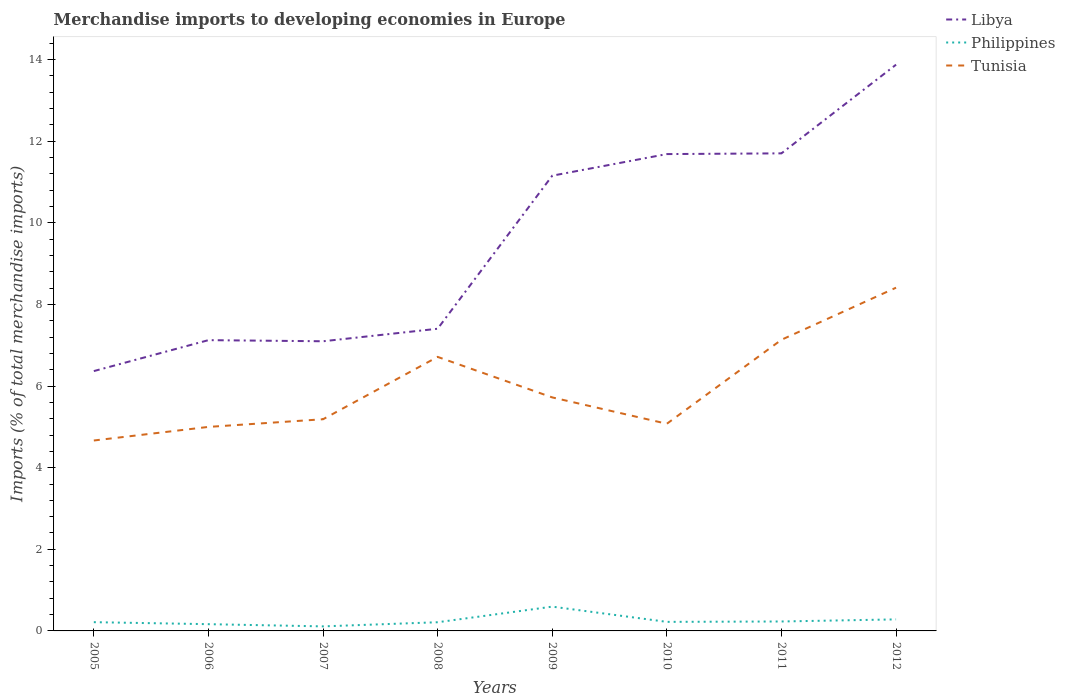Is the number of lines equal to the number of legend labels?
Provide a short and direct response. Yes. Across all years, what is the maximum percentage total merchandise imports in Philippines?
Give a very brief answer. 0.11. What is the total percentage total merchandise imports in Libya in the graph?
Offer a terse response. -4.6. What is the difference between the highest and the second highest percentage total merchandise imports in Libya?
Give a very brief answer. 7.51. Is the percentage total merchandise imports in Philippines strictly greater than the percentage total merchandise imports in Libya over the years?
Give a very brief answer. Yes. How many lines are there?
Your response must be concise. 3. What is the difference between two consecutive major ticks on the Y-axis?
Provide a short and direct response. 2. Are the values on the major ticks of Y-axis written in scientific E-notation?
Your answer should be very brief. No. How many legend labels are there?
Give a very brief answer. 3. What is the title of the graph?
Make the answer very short. Merchandise imports to developing economies in Europe. Does "Suriname" appear as one of the legend labels in the graph?
Your answer should be very brief. No. What is the label or title of the Y-axis?
Offer a terse response. Imports (% of total merchandise imports). What is the Imports (% of total merchandise imports) in Libya in 2005?
Offer a very short reply. 6.37. What is the Imports (% of total merchandise imports) of Philippines in 2005?
Your answer should be very brief. 0.21. What is the Imports (% of total merchandise imports) of Tunisia in 2005?
Give a very brief answer. 4.67. What is the Imports (% of total merchandise imports) in Libya in 2006?
Provide a succinct answer. 7.13. What is the Imports (% of total merchandise imports) of Philippines in 2006?
Ensure brevity in your answer.  0.17. What is the Imports (% of total merchandise imports) of Tunisia in 2006?
Keep it short and to the point. 5. What is the Imports (% of total merchandise imports) in Libya in 2007?
Provide a succinct answer. 7.1. What is the Imports (% of total merchandise imports) in Philippines in 2007?
Your response must be concise. 0.11. What is the Imports (% of total merchandise imports) of Tunisia in 2007?
Offer a terse response. 5.19. What is the Imports (% of total merchandise imports) in Libya in 2008?
Your answer should be very brief. 7.41. What is the Imports (% of total merchandise imports) of Philippines in 2008?
Provide a succinct answer. 0.21. What is the Imports (% of total merchandise imports) in Tunisia in 2008?
Provide a short and direct response. 6.72. What is the Imports (% of total merchandise imports) in Libya in 2009?
Make the answer very short. 11.16. What is the Imports (% of total merchandise imports) of Philippines in 2009?
Your answer should be very brief. 0.6. What is the Imports (% of total merchandise imports) of Tunisia in 2009?
Provide a succinct answer. 5.72. What is the Imports (% of total merchandise imports) in Libya in 2010?
Your response must be concise. 11.69. What is the Imports (% of total merchandise imports) in Philippines in 2010?
Make the answer very short. 0.22. What is the Imports (% of total merchandise imports) in Tunisia in 2010?
Keep it short and to the point. 5.08. What is the Imports (% of total merchandise imports) of Libya in 2011?
Give a very brief answer. 11.7. What is the Imports (% of total merchandise imports) in Philippines in 2011?
Keep it short and to the point. 0.23. What is the Imports (% of total merchandise imports) in Tunisia in 2011?
Offer a very short reply. 7.14. What is the Imports (% of total merchandise imports) of Libya in 2012?
Your answer should be very brief. 13.88. What is the Imports (% of total merchandise imports) in Philippines in 2012?
Ensure brevity in your answer.  0.28. What is the Imports (% of total merchandise imports) in Tunisia in 2012?
Offer a terse response. 8.41. Across all years, what is the maximum Imports (% of total merchandise imports) in Libya?
Offer a very short reply. 13.88. Across all years, what is the maximum Imports (% of total merchandise imports) of Philippines?
Keep it short and to the point. 0.6. Across all years, what is the maximum Imports (% of total merchandise imports) in Tunisia?
Offer a very short reply. 8.41. Across all years, what is the minimum Imports (% of total merchandise imports) of Libya?
Make the answer very short. 6.37. Across all years, what is the minimum Imports (% of total merchandise imports) of Philippines?
Offer a terse response. 0.11. Across all years, what is the minimum Imports (% of total merchandise imports) of Tunisia?
Provide a short and direct response. 4.67. What is the total Imports (% of total merchandise imports) in Libya in the graph?
Make the answer very short. 76.42. What is the total Imports (% of total merchandise imports) in Philippines in the graph?
Your response must be concise. 2.04. What is the total Imports (% of total merchandise imports) in Tunisia in the graph?
Offer a terse response. 47.91. What is the difference between the Imports (% of total merchandise imports) of Libya in 2005 and that in 2006?
Ensure brevity in your answer.  -0.76. What is the difference between the Imports (% of total merchandise imports) of Philippines in 2005 and that in 2006?
Keep it short and to the point. 0.05. What is the difference between the Imports (% of total merchandise imports) of Tunisia in 2005 and that in 2006?
Ensure brevity in your answer.  -0.33. What is the difference between the Imports (% of total merchandise imports) in Libya in 2005 and that in 2007?
Your answer should be very brief. -0.73. What is the difference between the Imports (% of total merchandise imports) of Philippines in 2005 and that in 2007?
Your answer should be compact. 0.1. What is the difference between the Imports (% of total merchandise imports) of Tunisia in 2005 and that in 2007?
Offer a very short reply. -0.52. What is the difference between the Imports (% of total merchandise imports) in Libya in 2005 and that in 2008?
Offer a very short reply. -1.04. What is the difference between the Imports (% of total merchandise imports) of Philippines in 2005 and that in 2008?
Your answer should be very brief. 0. What is the difference between the Imports (% of total merchandise imports) of Tunisia in 2005 and that in 2008?
Your answer should be very brief. -2.05. What is the difference between the Imports (% of total merchandise imports) in Libya in 2005 and that in 2009?
Provide a succinct answer. -4.79. What is the difference between the Imports (% of total merchandise imports) of Philippines in 2005 and that in 2009?
Your response must be concise. -0.38. What is the difference between the Imports (% of total merchandise imports) of Tunisia in 2005 and that in 2009?
Your answer should be compact. -1.06. What is the difference between the Imports (% of total merchandise imports) in Libya in 2005 and that in 2010?
Provide a succinct answer. -5.32. What is the difference between the Imports (% of total merchandise imports) in Philippines in 2005 and that in 2010?
Keep it short and to the point. -0.01. What is the difference between the Imports (% of total merchandise imports) in Tunisia in 2005 and that in 2010?
Make the answer very short. -0.41. What is the difference between the Imports (% of total merchandise imports) in Libya in 2005 and that in 2011?
Your answer should be compact. -5.34. What is the difference between the Imports (% of total merchandise imports) of Philippines in 2005 and that in 2011?
Provide a succinct answer. -0.02. What is the difference between the Imports (% of total merchandise imports) of Tunisia in 2005 and that in 2011?
Offer a terse response. -2.47. What is the difference between the Imports (% of total merchandise imports) of Libya in 2005 and that in 2012?
Offer a very short reply. -7.51. What is the difference between the Imports (% of total merchandise imports) in Philippines in 2005 and that in 2012?
Your answer should be very brief. -0.07. What is the difference between the Imports (% of total merchandise imports) in Tunisia in 2005 and that in 2012?
Offer a terse response. -3.75. What is the difference between the Imports (% of total merchandise imports) of Libya in 2006 and that in 2007?
Your response must be concise. 0.03. What is the difference between the Imports (% of total merchandise imports) in Philippines in 2006 and that in 2007?
Your response must be concise. 0.05. What is the difference between the Imports (% of total merchandise imports) of Tunisia in 2006 and that in 2007?
Keep it short and to the point. -0.19. What is the difference between the Imports (% of total merchandise imports) in Libya in 2006 and that in 2008?
Offer a terse response. -0.28. What is the difference between the Imports (% of total merchandise imports) of Philippines in 2006 and that in 2008?
Offer a terse response. -0.05. What is the difference between the Imports (% of total merchandise imports) in Tunisia in 2006 and that in 2008?
Offer a terse response. -1.72. What is the difference between the Imports (% of total merchandise imports) of Libya in 2006 and that in 2009?
Offer a very short reply. -4.03. What is the difference between the Imports (% of total merchandise imports) of Philippines in 2006 and that in 2009?
Make the answer very short. -0.43. What is the difference between the Imports (% of total merchandise imports) of Tunisia in 2006 and that in 2009?
Offer a very short reply. -0.72. What is the difference between the Imports (% of total merchandise imports) of Libya in 2006 and that in 2010?
Keep it short and to the point. -4.56. What is the difference between the Imports (% of total merchandise imports) in Philippines in 2006 and that in 2010?
Provide a succinct answer. -0.06. What is the difference between the Imports (% of total merchandise imports) in Tunisia in 2006 and that in 2010?
Ensure brevity in your answer.  -0.08. What is the difference between the Imports (% of total merchandise imports) in Libya in 2006 and that in 2011?
Keep it short and to the point. -4.58. What is the difference between the Imports (% of total merchandise imports) in Philippines in 2006 and that in 2011?
Provide a succinct answer. -0.07. What is the difference between the Imports (% of total merchandise imports) of Tunisia in 2006 and that in 2011?
Keep it short and to the point. -2.14. What is the difference between the Imports (% of total merchandise imports) in Libya in 2006 and that in 2012?
Offer a terse response. -6.75. What is the difference between the Imports (% of total merchandise imports) of Philippines in 2006 and that in 2012?
Your answer should be compact. -0.12. What is the difference between the Imports (% of total merchandise imports) of Tunisia in 2006 and that in 2012?
Your answer should be compact. -3.41. What is the difference between the Imports (% of total merchandise imports) in Libya in 2007 and that in 2008?
Make the answer very short. -0.31. What is the difference between the Imports (% of total merchandise imports) of Philippines in 2007 and that in 2008?
Offer a very short reply. -0.1. What is the difference between the Imports (% of total merchandise imports) in Tunisia in 2007 and that in 2008?
Your response must be concise. -1.53. What is the difference between the Imports (% of total merchandise imports) of Libya in 2007 and that in 2009?
Keep it short and to the point. -4.06. What is the difference between the Imports (% of total merchandise imports) of Philippines in 2007 and that in 2009?
Ensure brevity in your answer.  -0.48. What is the difference between the Imports (% of total merchandise imports) in Tunisia in 2007 and that in 2009?
Your response must be concise. -0.53. What is the difference between the Imports (% of total merchandise imports) of Libya in 2007 and that in 2010?
Provide a succinct answer. -4.59. What is the difference between the Imports (% of total merchandise imports) of Philippines in 2007 and that in 2010?
Your response must be concise. -0.11. What is the difference between the Imports (% of total merchandise imports) in Tunisia in 2007 and that in 2010?
Offer a terse response. 0.11. What is the difference between the Imports (% of total merchandise imports) of Libya in 2007 and that in 2011?
Give a very brief answer. -4.6. What is the difference between the Imports (% of total merchandise imports) of Philippines in 2007 and that in 2011?
Provide a short and direct response. -0.12. What is the difference between the Imports (% of total merchandise imports) in Tunisia in 2007 and that in 2011?
Your answer should be compact. -1.95. What is the difference between the Imports (% of total merchandise imports) of Libya in 2007 and that in 2012?
Keep it short and to the point. -6.78. What is the difference between the Imports (% of total merchandise imports) in Philippines in 2007 and that in 2012?
Ensure brevity in your answer.  -0.17. What is the difference between the Imports (% of total merchandise imports) of Tunisia in 2007 and that in 2012?
Provide a short and direct response. -3.22. What is the difference between the Imports (% of total merchandise imports) in Libya in 2008 and that in 2009?
Ensure brevity in your answer.  -3.75. What is the difference between the Imports (% of total merchandise imports) in Philippines in 2008 and that in 2009?
Your answer should be compact. -0.38. What is the difference between the Imports (% of total merchandise imports) of Tunisia in 2008 and that in 2009?
Your response must be concise. 0.99. What is the difference between the Imports (% of total merchandise imports) in Libya in 2008 and that in 2010?
Give a very brief answer. -4.28. What is the difference between the Imports (% of total merchandise imports) in Philippines in 2008 and that in 2010?
Make the answer very short. -0.01. What is the difference between the Imports (% of total merchandise imports) of Tunisia in 2008 and that in 2010?
Make the answer very short. 1.64. What is the difference between the Imports (% of total merchandise imports) in Libya in 2008 and that in 2011?
Provide a short and direct response. -4.3. What is the difference between the Imports (% of total merchandise imports) of Philippines in 2008 and that in 2011?
Give a very brief answer. -0.02. What is the difference between the Imports (% of total merchandise imports) in Tunisia in 2008 and that in 2011?
Your response must be concise. -0.42. What is the difference between the Imports (% of total merchandise imports) in Libya in 2008 and that in 2012?
Provide a succinct answer. -6.47. What is the difference between the Imports (% of total merchandise imports) in Philippines in 2008 and that in 2012?
Provide a succinct answer. -0.07. What is the difference between the Imports (% of total merchandise imports) in Tunisia in 2008 and that in 2012?
Provide a short and direct response. -1.7. What is the difference between the Imports (% of total merchandise imports) in Libya in 2009 and that in 2010?
Your response must be concise. -0.53. What is the difference between the Imports (% of total merchandise imports) in Philippines in 2009 and that in 2010?
Make the answer very short. 0.37. What is the difference between the Imports (% of total merchandise imports) of Tunisia in 2009 and that in 2010?
Offer a very short reply. 0.65. What is the difference between the Imports (% of total merchandise imports) in Libya in 2009 and that in 2011?
Make the answer very short. -0.55. What is the difference between the Imports (% of total merchandise imports) of Philippines in 2009 and that in 2011?
Give a very brief answer. 0.36. What is the difference between the Imports (% of total merchandise imports) in Tunisia in 2009 and that in 2011?
Keep it short and to the point. -1.41. What is the difference between the Imports (% of total merchandise imports) in Libya in 2009 and that in 2012?
Keep it short and to the point. -2.72. What is the difference between the Imports (% of total merchandise imports) in Philippines in 2009 and that in 2012?
Provide a succinct answer. 0.31. What is the difference between the Imports (% of total merchandise imports) of Tunisia in 2009 and that in 2012?
Your answer should be very brief. -2.69. What is the difference between the Imports (% of total merchandise imports) in Libya in 2010 and that in 2011?
Your answer should be very brief. -0.02. What is the difference between the Imports (% of total merchandise imports) of Philippines in 2010 and that in 2011?
Ensure brevity in your answer.  -0.01. What is the difference between the Imports (% of total merchandise imports) of Tunisia in 2010 and that in 2011?
Your answer should be compact. -2.06. What is the difference between the Imports (% of total merchandise imports) in Libya in 2010 and that in 2012?
Your response must be concise. -2.19. What is the difference between the Imports (% of total merchandise imports) of Philippines in 2010 and that in 2012?
Offer a very short reply. -0.06. What is the difference between the Imports (% of total merchandise imports) in Tunisia in 2010 and that in 2012?
Keep it short and to the point. -3.33. What is the difference between the Imports (% of total merchandise imports) of Libya in 2011 and that in 2012?
Offer a terse response. -2.17. What is the difference between the Imports (% of total merchandise imports) of Philippines in 2011 and that in 2012?
Your answer should be compact. -0.05. What is the difference between the Imports (% of total merchandise imports) of Tunisia in 2011 and that in 2012?
Make the answer very short. -1.28. What is the difference between the Imports (% of total merchandise imports) of Libya in 2005 and the Imports (% of total merchandise imports) of Philippines in 2006?
Offer a very short reply. 6.2. What is the difference between the Imports (% of total merchandise imports) of Libya in 2005 and the Imports (% of total merchandise imports) of Tunisia in 2006?
Ensure brevity in your answer.  1.37. What is the difference between the Imports (% of total merchandise imports) in Philippines in 2005 and the Imports (% of total merchandise imports) in Tunisia in 2006?
Offer a terse response. -4.79. What is the difference between the Imports (% of total merchandise imports) in Libya in 2005 and the Imports (% of total merchandise imports) in Philippines in 2007?
Keep it short and to the point. 6.26. What is the difference between the Imports (% of total merchandise imports) in Libya in 2005 and the Imports (% of total merchandise imports) in Tunisia in 2007?
Provide a succinct answer. 1.18. What is the difference between the Imports (% of total merchandise imports) in Philippines in 2005 and the Imports (% of total merchandise imports) in Tunisia in 2007?
Provide a succinct answer. -4.97. What is the difference between the Imports (% of total merchandise imports) of Libya in 2005 and the Imports (% of total merchandise imports) of Philippines in 2008?
Ensure brevity in your answer.  6.15. What is the difference between the Imports (% of total merchandise imports) in Libya in 2005 and the Imports (% of total merchandise imports) in Tunisia in 2008?
Your response must be concise. -0.35. What is the difference between the Imports (% of total merchandise imports) in Philippines in 2005 and the Imports (% of total merchandise imports) in Tunisia in 2008?
Provide a short and direct response. -6.5. What is the difference between the Imports (% of total merchandise imports) of Libya in 2005 and the Imports (% of total merchandise imports) of Philippines in 2009?
Give a very brief answer. 5.77. What is the difference between the Imports (% of total merchandise imports) of Libya in 2005 and the Imports (% of total merchandise imports) of Tunisia in 2009?
Offer a terse response. 0.65. What is the difference between the Imports (% of total merchandise imports) of Philippines in 2005 and the Imports (% of total merchandise imports) of Tunisia in 2009?
Provide a short and direct response. -5.51. What is the difference between the Imports (% of total merchandise imports) of Libya in 2005 and the Imports (% of total merchandise imports) of Philippines in 2010?
Provide a succinct answer. 6.15. What is the difference between the Imports (% of total merchandise imports) in Libya in 2005 and the Imports (% of total merchandise imports) in Tunisia in 2010?
Your answer should be very brief. 1.29. What is the difference between the Imports (% of total merchandise imports) of Philippines in 2005 and the Imports (% of total merchandise imports) of Tunisia in 2010?
Offer a terse response. -4.86. What is the difference between the Imports (% of total merchandise imports) in Libya in 2005 and the Imports (% of total merchandise imports) in Philippines in 2011?
Provide a succinct answer. 6.14. What is the difference between the Imports (% of total merchandise imports) in Libya in 2005 and the Imports (% of total merchandise imports) in Tunisia in 2011?
Provide a succinct answer. -0.77. What is the difference between the Imports (% of total merchandise imports) in Philippines in 2005 and the Imports (% of total merchandise imports) in Tunisia in 2011?
Keep it short and to the point. -6.92. What is the difference between the Imports (% of total merchandise imports) in Libya in 2005 and the Imports (% of total merchandise imports) in Philippines in 2012?
Offer a terse response. 6.08. What is the difference between the Imports (% of total merchandise imports) in Libya in 2005 and the Imports (% of total merchandise imports) in Tunisia in 2012?
Make the answer very short. -2.04. What is the difference between the Imports (% of total merchandise imports) of Philippines in 2005 and the Imports (% of total merchandise imports) of Tunisia in 2012?
Your answer should be compact. -8.2. What is the difference between the Imports (% of total merchandise imports) of Libya in 2006 and the Imports (% of total merchandise imports) of Philippines in 2007?
Give a very brief answer. 7.01. What is the difference between the Imports (% of total merchandise imports) in Libya in 2006 and the Imports (% of total merchandise imports) in Tunisia in 2007?
Offer a terse response. 1.94. What is the difference between the Imports (% of total merchandise imports) in Philippines in 2006 and the Imports (% of total merchandise imports) in Tunisia in 2007?
Your response must be concise. -5.02. What is the difference between the Imports (% of total merchandise imports) in Libya in 2006 and the Imports (% of total merchandise imports) in Philippines in 2008?
Your answer should be very brief. 6.91. What is the difference between the Imports (% of total merchandise imports) of Libya in 2006 and the Imports (% of total merchandise imports) of Tunisia in 2008?
Ensure brevity in your answer.  0.41. What is the difference between the Imports (% of total merchandise imports) in Philippines in 2006 and the Imports (% of total merchandise imports) in Tunisia in 2008?
Your response must be concise. -6.55. What is the difference between the Imports (% of total merchandise imports) in Libya in 2006 and the Imports (% of total merchandise imports) in Philippines in 2009?
Make the answer very short. 6.53. What is the difference between the Imports (% of total merchandise imports) of Libya in 2006 and the Imports (% of total merchandise imports) of Tunisia in 2009?
Give a very brief answer. 1.4. What is the difference between the Imports (% of total merchandise imports) in Philippines in 2006 and the Imports (% of total merchandise imports) in Tunisia in 2009?
Give a very brief answer. -5.56. What is the difference between the Imports (% of total merchandise imports) of Libya in 2006 and the Imports (% of total merchandise imports) of Philippines in 2010?
Provide a short and direct response. 6.9. What is the difference between the Imports (% of total merchandise imports) of Libya in 2006 and the Imports (% of total merchandise imports) of Tunisia in 2010?
Make the answer very short. 2.05. What is the difference between the Imports (% of total merchandise imports) of Philippines in 2006 and the Imports (% of total merchandise imports) of Tunisia in 2010?
Keep it short and to the point. -4.91. What is the difference between the Imports (% of total merchandise imports) of Libya in 2006 and the Imports (% of total merchandise imports) of Philippines in 2011?
Make the answer very short. 6.89. What is the difference between the Imports (% of total merchandise imports) in Libya in 2006 and the Imports (% of total merchandise imports) in Tunisia in 2011?
Offer a very short reply. -0.01. What is the difference between the Imports (% of total merchandise imports) of Philippines in 2006 and the Imports (% of total merchandise imports) of Tunisia in 2011?
Keep it short and to the point. -6.97. What is the difference between the Imports (% of total merchandise imports) in Libya in 2006 and the Imports (% of total merchandise imports) in Philippines in 2012?
Ensure brevity in your answer.  6.84. What is the difference between the Imports (% of total merchandise imports) in Libya in 2006 and the Imports (% of total merchandise imports) in Tunisia in 2012?
Ensure brevity in your answer.  -1.29. What is the difference between the Imports (% of total merchandise imports) in Philippines in 2006 and the Imports (% of total merchandise imports) in Tunisia in 2012?
Your answer should be compact. -8.25. What is the difference between the Imports (% of total merchandise imports) in Libya in 2007 and the Imports (% of total merchandise imports) in Philippines in 2008?
Ensure brevity in your answer.  6.89. What is the difference between the Imports (% of total merchandise imports) in Libya in 2007 and the Imports (% of total merchandise imports) in Tunisia in 2008?
Make the answer very short. 0.38. What is the difference between the Imports (% of total merchandise imports) in Philippines in 2007 and the Imports (% of total merchandise imports) in Tunisia in 2008?
Give a very brief answer. -6.6. What is the difference between the Imports (% of total merchandise imports) of Libya in 2007 and the Imports (% of total merchandise imports) of Philippines in 2009?
Offer a very short reply. 6.5. What is the difference between the Imports (% of total merchandise imports) of Libya in 2007 and the Imports (% of total merchandise imports) of Tunisia in 2009?
Your response must be concise. 1.38. What is the difference between the Imports (% of total merchandise imports) in Philippines in 2007 and the Imports (% of total merchandise imports) in Tunisia in 2009?
Offer a terse response. -5.61. What is the difference between the Imports (% of total merchandise imports) of Libya in 2007 and the Imports (% of total merchandise imports) of Philippines in 2010?
Your answer should be compact. 6.88. What is the difference between the Imports (% of total merchandise imports) in Libya in 2007 and the Imports (% of total merchandise imports) in Tunisia in 2010?
Make the answer very short. 2.02. What is the difference between the Imports (% of total merchandise imports) in Philippines in 2007 and the Imports (% of total merchandise imports) in Tunisia in 2010?
Provide a short and direct response. -4.97. What is the difference between the Imports (% of total merchandise imports) in Libya in 2007 and the Imports (% of total merchandise imports) in Philippines in 2011?
Offer a terse response. 6.87. What is the difference between the Imports (% of total merchandise imports) of Libya in 2007 and the Imports (% of total merchandise imports) of Tunisia in 2011?
Ensure brevity in your answer.  -0.04. What is the difference between the Imports (% of total merchandise imports) in Philippines in 2007 and the Imports (% of total merchandise imports) in Tunisia in 2011?
Your response must be concise. -7.02. What is the difference between the Imports (% of total merchandise imports) in Libya in 2007 and the Imports (% of total merchandise imports) in Philippines in 2012?
Your response must be concise. 6.82. What is the difference between the Imports (% of total merchandise imports) of Libya in 2007 and the Imports (% of total merchandise imports) of Tunisia in 2012?
Ensure brevity in your answer.  -1.31. What is the difference between the Imports (% of total merchandise imports) of Philippines in 2007 and the Imports (% of total merchandise imports) of Tunisia in 2012?
Make the answer very short. -8.3. What is the difference between the Imports (% of total merchandise imports) of Libya in 2008 and the Imports (% of total merchandise imports) of Philippines in 2009?
Your response must be concise. 6.81. What is the difference between the Imports (% of total merchandise imports) in Libya in 2008 and the Imports (% of total merchandise imports) in Tunisia in 2009?
Make the answer very short. 1.68. What is the difference between the Imports (% of total merchandise imports) in Philippines in 2008 and the Imports (% of total merchandise imports) in Tunisia in 2009?
Give a very brief answer. -5.51. What is the difference between the Imports (% of total merchandise imports) of Libya in 2008 and the Imports (% of total merchandise imports) of Philippines in 2010?
Provide a short and direct response. 7.18. What is the difference between the Imports (% of total merchandise imports) of Libya in 2008 and the Imports (% of total merchandise imports) of Tunisia in 2010?
Offer a terse response. 2.33. What is the difference between the Imports (% of total merchandise imports) of Philippines in 2008 and the Imports (% of total merchandise imports) of Tunisia in 2010?
Offer a terse response. -4.86. What is the difference between the Imports (% of total merchandise imports) of Libya in 2008 and the Imports (% of total merchandise imports) of Philippines in 2011?
Your response must be concise. 7.17. What is the difference between the Imports (% of total merchandise imports) in Libya in 2008 and the Imports (% of total merchandise imports) in Tunisia in 2011?
Your answer should be very brief. 0.27. What is the difference between the Imports (% of total merchandise imports) of Philippines in 2008 and the Imports (% of total merchandise imports) of Tunisia in 2011?
Offer a very short reply. -6.92. What is the difference between the Imports (% of total merchandise imports) of Libya in 2008 and the Imports (% of total merchandise imports) of Philippines in 2012?
Make the answer very short. 7.12. What is the difference between the Imports (% of total merchandise imports) of Libya in 2008 and the Imports (% of total merchandise imports) of Tunisia in 2012?
Make the answer very short. -1.01. What is the difference between the Imports (% of total merchandise imports) in Philippines in 2008 and the Imports (% of total merchandise imports) in Tunisia in 2012?
Provide a succinct answer. -8.2. What is the difference between the Imports (% of total merchandise imports) of Libya in 2009 and the Imports (% of total merchandise imports) of Philippines in 2010?
Ensure brevity in your answer.  10.93. What is the difference between the Imports (% of total merchandise imports) of Libya in 2009 and the Imports (% of total merchandise imports) of Tunisia in 2010?
Make the answer very short. 6.08. What is the difference between the Imports (% of total merchandise imports) of Philippines in 2009 and the Imports (% of total merchandise imports) of Tunisia in 2010?
Make the answer very short. -4.48. What is the difference between the Imports (% of total merchandise imports) in Libya in 2009 and the Imports (% of total merchandise imports) in Philippines in 2011?
Your response must be concise. 10.92. What is the difference between the Imports (% of total merchandise imports) of Libya in 2009 and the Imports (% of total merchandise imports) of Tunisia in 2011?
Give a very brief answer. 4.02. What is the difference between the Imports (% of total merchandise imports) of Philippines in 2009 and the Imports (% of total merchandise imports) of Tunisia in 2011?
Provide a succinct answer. -6.54. What is the difference between the Imports (% of total merchandise imports) in Libya in 2009 and the Imports (% of total merchandise imports) in Philippines in 2012?
Keep it short and to the point. 10.87. What is the difference between the Imports (% of total merchandise imports) of Libya in 2009 and the Imports (% of total merchandise imports) of Tunisia in 2012?
Make the answer very short. 2.74. What is the difference between the Imports (% of total merchandise imports) of Philippines in 2009 and the Imports (% of total merchandise imports) of Tunisia in 2012?
Provide a succinct answer. -7.82. What is the difference between the Imports (% of total merchandise imports) in Libya in 2010 and the Imports (% of total merchandise imports) in Philippines in 2011?
Provide a succinct answer. 11.45. What is the difference between the Imports (% of total merchandise imports) in Libya in 2010 and the Imports (% of total merchandise imports) in Tunisia in 2011?
Offer a very short reply. 4.55. What is the difference between the Imports (% of total merchandise imports) of Philippines in 2010 and the Imports (% of total merchandise imports) of Tunisia in 2011?
Keep it short and to the point. -6.91. What is the difference between the Imports (% of total merchandise imports) in Libya in 2010 and the Imports (% of total merchandise imports) in Philippines in 2012?
Ensure brevity in your answer.  11.4. What is the difference between the Imports (% of total merchandise imports) of Libya in 2010 and the Imports (% of total merchandise imports) of Tunisia in 2012?
Ensure brevity in your answer.  3.27. What is the difference between the Imports (% of total merchandise imports) of Philippines in 2010 and the Imports (% of total merchandise imports) of Tunisia in 2012?
Make the answer very short. -8.19. What is the difference between the Imports (% of total merchandise imports) of Libya in 2011 and the Imports (% of total merchandise imports) of Philippines in 2012?
Provide a succinct answer. 11.42. What is the difference between the Imports (% of total merchandise imports) in Libya in 2011 and the Imports (% of total merchandise imports) in Tunisia in 2012?
Your response must be concise. 3.29. What is the difference between the Imports (% of total merchandise imports) of Philippines in 2011 and the Imports (% of total merchandise imports) of Tunisia in 2012?
Offer a very short reply. -8.18. What is the average Imports (% of total merchandise imports) in Libya per year?
Provide a short and direct response. 9.55. What is the average Imports (% of total merchandise imports) of Philippines per year?
Your response must be concise. 0.25. What is the average Imports (% of total merchandise imports) in Tunisia per year?
Provide a succinct answer. 5.99. In the year 2005, what is the difference between the Imports (% of total merchandise imports) in Libya and Imports (% of total merchandise imports) in Philippines?
Ensure brevity in your answer.  6.15. In the year 2005, what is the difference between the Imports (% of total merchandise imports) of Libya and Imports (% of total merchandise imports) of Tunisia?
Your answer should be very brief. 1.7. In the year 2005, what is the difference between the Imports (% of total merchandise imports) in Philippines and Imports (% of total merchandise imports) in Tunisia?
Provide a short and direct response. -4.45. In the year 2006, what is the difference between the Imports (% of total merchandise imports) in Libya and Imports (% of total merchandise imports) in Philippines?
Give a very brief answer. 6.96. In the year 2006, what is the difference between the Imports (% of total merchandise imports) of Libya and Imports (% of total merchandise imports) of Tunisia?
Your answer should be very brief. 2.13. In the year 2006, what is the difference between the Imports (% of total merchandise imports) of Philippines and Imports (% of total merchandise imports) of Tunisia?
Your answer should be very brief. -4.83. In the year 2007, what is the difference between the Imports (% of total merchandise imports) in Libya and Imports (% of total merchandise imports) in Philippines?
Provide a short and direct response. 6.99. In the year 2007, what is the difference between the Imports (% of total merchandise imports) of Libya and Imports (% of total merchandise imports) of Tunisia?
Your answer should be very brief. 1.91. In the year 2007, what is the difference between the Imports (% of total merchandise imports) of Philippines and Imports (% of total merchandise imports) of Tunisia?
Offer a very short reply. -5.08. In the year 2008, what is the difference between the Imports (% of total merchandise imports) in Libya and Imports (% of total merchandise imports) in Philippines?
Make the answer very short. 7.19. In the year 2008, what is the difference between the Imports (% of total merchandise imports) in Libya and Imports (% of total merchandise imports) in Tunisia?
Give a very brief answer. 0.69. In the year 2008, what is the difference between the Imports (% of total merchandise imports) of Philippines and Imports (% of total merchandise imports) of Tunisia?
Your answer should be compact. -6.5. In the year 2009, what is the difference between the Imports (% of total merchandise imports) in Libya and Imports (% of total merchandise imports) in Philippines?
Ensure brevity in your answer.  10.56. In the year 2009, what is the difference between the Imports (% of total merchandise imports) in Libya and Imports (% of total merchandise imports) in Tunisia?
Provide a short and direct response. 5.43. In the year 2009, what is the difference between the Imports (% of total merchandise imports) in Philippines and Imports (% of total merchandise imports) in Tunisia?
Your answer should be compact. -5.13. In the year 2010, what is the difference between the Imports (% of total merchandise imports) of Libya and Imports (% of total merchandise imports) of Philippines?
Offer a terse response. 11.46. In the year 2010, what is the difference between the Imports (% of total merchandise imports) of Libya and Imports (% of total merchandise imports) of Tunisia?
Provide a succinct answer. 6.61. In the year 2010, what is the difference between the Imports (% of total merchandise imports) of Philippines and Imports (% of total merchandise imports) of Tunisia?
Offer a terse response. -4.85. In the year 2011, what is the difference between the Imports (% of total merchandise imports) in Libya and Imports (% of total merchandise imports) in Philippines?
Keep it short and to the point. 11.47. In the year 2011, what is the difference between the Imports (% of total merchandise imports) in Libya and Imports (% of total merchandise imports) in Tunisia?
Give a very brief answer. 4.57. In the year 2011, what is the difference between the Imports (% of total merchandise imports) of Philippines and Imports (% of total merchandise imports) of Tunisia?
Make the answer very short. -6.9. In the year 2012, what is the difference between the Imports (% of total merchandise imports) in Libya and Imports (% of total merchandise imports) in Philippines?
Your response must be concise. 13.59. In the year 2012, what is the difference between the Imports (% of total merchandise imports) of Libya and Imports (% of total merchandise imports) of Tunisia?
Provide a succinct answer. 5.47. In the year 2012, what is the difference between the Imports (% of total merchandise imports) of Philippines and Imports (% of total merchandise imports) of Tunisia?
Keep it short and to the point. -8.13. What is the ratio of the Imports (% of total merchandise imports) of Libya in 2005 to that in 2006?
Offer a terse response. 0.89. What is the ratio of the Imports (% of total merchandise imports) of Philippines in 2005 to that in 2006?
Make the answer very short. 1.3. What is the ratio of the Imports (% of total merchandise imports) of Tunisia in 2005 to that in 2006?
Provide a succinct answer. 0.93. What is the ratio of the Imports (% of total merchandise imports) of Libya in 2005 to that in 2007?
Your response must be concise. 0.9. What is the ratio of the Imports (% of total merchandise imports) in Philippines in 2005 to that in 2007?
Your answer should be compact. 1.93. What is the ratio of the Imports (% of total merchandise imports) of Tunisia in 2005 to that in 2007?
Keep it short and to the point. 0.9. What is the ratio of the Imports (% of total merchandise imports) of Libya in 2005 to that in 2008?
Ensure brevity in your answer.  0.86. What is the ratio of the Imports (% of total merchandise imports) in Tunisia in 2005 to that in 2008?
Give a very brief answer. 0.69. What is the ratio of the Imports (% of total merchandise imports) of Libya in 2005 to that in 2009?
Offer a very short reply. 0.57. What is the ratio of the Imports (% of total merchandise imports) of Philippines in 2005 to that in 2009?
Give a very brief answer. 0.36. What is the ratio of the Imports (% of total merchandise imports) of Tunisia in 2005 to that in 2009?
Keep it short and to the point. 0.82. What is the ratio of the Imports (% of total merchandise imports) of Libya in 2005 to that in 2010?
Make the answer very short. 0.54. What is the ratio of the Imports (% of total merchandise imports) of Philippines in 2005 to that in 2010?
Offer a very short reply. 0.97. What is the ratio of the Imports (% of total merchandise imports) of Tunisia in 2005 to that in 2010?
Provide a succinct answer. 0.92. What is the ratio of the Imports (% of total merchandise imports) of Libya in 2005 to that in 2011?
Provide a succinct answer. 0.54. What is the ratio of the Imports (% of total merchandise imports) of Philippines in 2005 to that in 2011?
Offer a terse response. 0.93. What is the ratio of the Imports (% of total merchandise imports) of Tunisia in 2005 to that in 2011?
Ensure brevity in your answer.  0.65. What is the ratio of the Imports (% of total merchandise imports) in Libya in 2005 to that in 2012?
Your answer should be very brief. 0.46. What is the ratio of the Imports (% of total merchandise imports) in Philippines in 2005 to that in 2012?
Offer a very short reply. 0.76. What is the ratio of the Imports (% of total merchandise imports) in Tunisia in 2005 to that in 2012?
Your answer should be compact. 0.55. What is the ratio of the Imports (% of total merchandise imports) of Libya in 2006 to that in 2007?
Provide a succinct answer. 1. What is the ratio of the Imports (% of total merchandise imports) in Philippines in 2006 to that in 2007?
Your response must be concise. 1.49. What is the ratio of the Imports (% of total merchandise imports) in Tunisia in 2006 to that in 2007?
Offer a very short reply. 0.96. What is the ratio of the Imports (% of total merchandise imports) of Libya in 2006 to that in 2008?
Offer a terse response. 0.96. What is the ratio of the Imports (% of total merchandise imports) of Philippines in 2006 to that in 2008?
Offer a very short reply. 0.78. What is the ratio of the Imports (% of total merchandise imports) of Tunisia in 2006 to that in 2008?
Provide a succinct answer. 0.74. What is the ratio of the Imports (% of total merchandise imports) of Libya in 2006 to that in 2009?
Provide a succinct answer. 0.64. What is the ratio of the Imports (% of total merchandise imports) of Philippines in 2006 to that in 2009?
Give a very brief answer. 0.28. What is the ratio of the Imports (% of total merchandise imports) of Tunisia in 2006 to that in 2009?
Provide a succinct answer. 0.87. What is the ratio of the Imports (% of total merchandise imports) of Libya in 2006 to that in 2010?
Offer a very short reply. 0.61. What is the ratio of the Imports (% of total merchandise imports) of Philippines in 2006 to that in 2010?
Provide a succinct answer. 0.75. What is the ratio of the Imports (% of total merchandise imports) of Tunisia in 2006 to that in 2010?
Provide a short and direct response. 0.98. What is the ratio of the Imports (% of total merchandise imports) in Libya in 2006 to that in 2011?
Make the answer very short. 0.61. What is the ratio of the Imports (% of total merchandise imports) in Philippines in 2006 to that in 2011?
Provide a succinct answer. 0.72. What is the ratio of the Imports (% of total merchandise imports) in Tunisia in 2006 to that in 2011?
Ensure brevity in your answer.  0.7. What is the ratio of the Imports (% of total merchandise imports) in Libya in 2006 to that in 2012?
Keep it short and to the point. 0.51. What is the ratio of the Imports (% of total merchandise imports) of Philippines in 2006 to that in 2012?
Make the answer very short. 0.58. What is the ratio of the Imports (% of total merchandise imports) of Tunisia in 2006 to that in 2012?
Your answer should be compact. 0.59. What is the ratio of the Imports (% of total merchandise imports) in Libya in 2007 to that in 2008?
Give a very brief answer. 0.96. What is the ratio of the Imports (% of total merchandise imports) in Philippines in 2007 to that in 2008?
Provide a succinct answer. 0.52. What is the ratio of the Imports (% of total merchandise imports) in Tunisia in 2007 to that in 2008?
Give a very brief answer. 0.77. What is the ratio of the Imports (% of total merchandise imports) in Libya in 2007 to that in 2009?
Keep it short and to the point. 0.64. What is the ratio of the Imports (% of total merchandise imports) of Philippines in 2007 to that in 2009?
Keep it short and to the point. 0.19. What is the ratio of the Imports (% of total merchandise imports) in Tunisia in 2007 to that in 2009?
Ensure brevity in your answer.  0.91. What is the ratio of the Imports (% of total merchandise imports) of Libya in 2007 to that in 2010?
Offer a very short reply. 0.61. What is the ratio of the Imports (% of total merchandise imports) in Philippines in 2007 to that in 2010?
Provide a short and direct response. 0.5. What is the ratio of the Imports (% of total merchandise imports) of Tunisia in 2007 to that in 2010?
Make the answer very short. 1.02. What is the ratio of the Imports (% of total merchandise imports) in Libya in 2007 to that in 2011?
Offer a very short reply. 0.61. What is the ratio of the Imports (% of total merchandise imports) of Philippines in 2007 to that in 2011?
Provide a short and direct response. 0.48. What is the ratio of the Imports (% of total merchandise imports) in Tunisia in 2007 to that in 2011?
Provide a short and direct response. 0.73. What is the ratio of the Imports (% of total merchandise imports) of Libya in 2007 to that in 2012?
Provide a short and direct response. 0.51. What is the ratio of the Imports (% of total merchandise imports) of Philippines in 2007 to that in 2012?
Give a very brief answer. 0.39. What is the ratio of the Imports (% of total merchandise imports) of Tunisia in 2007 to that in 2012?
Provide a short and direct response. 0.62. What is the ratio of the Imports (% of total merchandise imports) of Libya in 2008 to that in 2009?
Provide a succinct answer. 0.66. What is the ratio of the Imports (% of total merchandise imports) of Philippines in 2008 to that in 2009?
Offer a terse response. 0.36. What is the ratio of the Imports (% of total merchandise imports) of Tunisia in 2008 to that in 2009?
Ensure brevity in your answer.  1.17. What is the ratio of the Imports (% of total merchandise imports) of Libya in 2008 to that in 2010?
Provide a succinct answer. 0.63. What is the ratio of the Imports (% of total merchandise imports) in Tunisia in 2008 to that in 2010?
Give a very brief answer. 1.32. What is the ratio of the Imports (% of total merchandise imports) in Libya in 2008 to that in 2011?
Provide a short and direct response. 0.63. What is the ratio of the Imports (% of total merchandise imports) of Philippines in 2008 to that in 2011?
Your response must be concise. 0.92. What is the ratio of the Imports (% of total merchandise imports) in Tunisia in 2008 to that in 2011?
Offer a very short reply. 0.94. What is the ratio of the Imports (% of total merchandise imports) in Libya in 2008 to that in 2012?
Ensure brevity in your answer.  0.53. What is the ratio of the Imports (% of total merchandise imports) of Philippines in 2008 to that in 2012?
Your response must be concise. 0.75. What is the ratio of the Imports (% of total merchandise imports) of Tunisia in 2008 to that in 2012?
Ensure brevity in your answer.  0.8. What is the ratio of the Imports (% of total merchandise imports) of Libya in 2009 to that in 2010?
Offer a terse response. 0.95. What is the ratio of the Imports (% of total merchandise imports) in Philippines in 2009 to that in 2010?
Your answer should be very brief. 2.68. What is the ratio of the Imports (% of total merchandise imports) of Tunisia in 2009 to that in 2010?
Your response must be concise. 1.13. What is the ratio of the Imports (% of total merchandise imports) in Libya in 2009 to that in 2011?
Offer a very short reply. 0.95. What is the ratio of the Imports (% of total merchandise imports) of Philippines in 2009 to that in 2011?
Make the answer very short. 2.57. What is the ratio of the Imports (% of total merchandise imports) of Tunisia in 2009 to that in 2011?
Offer a very short reply. 0.8. What is the ratio of the Imports (% of total merchandise imports) of Libya in 2009 to that in 2012?
Offer a very short reply. 0.8. What is the ratio of the Imports (% of total merchandise imports) in Philippines in 2009 to that in 2012?
Offer a very short reply. 2.1. What is the ratio of the Imports (% of total merchandise imports) of Tunisia in 2009 to that in 2012?
Keep it short and to the point. 0.68. What is the ratio of the Imports (% of total merchandise imports) of Libya in 2010 to that in 2011?
Offer a terse response. 1. What is the ratio of the Imports (% of total merchandise imports) in Philippines in 2010 to that in 2011?
Provide a short and direct response. 0.96. What is the ratio of the Imports (% of total merchandise imports) of Tunisia in 2010 to that in 2011?
Your answer should be compact. 0.71. What is the ratio of the Imports (% of total merchandise imports) of Libya in 2010 to that in 2012?
Give a very brief answer. 0.84. What is the ratio of the Imports (% of total merchandise imports) in Philippines in 2010 to that in 2012?
Your answer should be compact. 0.78. What is the ratio of the Imports (% of total merchandise imports) of Tunisia in 2010 to that in 2012?
Your answer should be very brief. 0.6. What is the ratio of the Imports (% of total merchandise imports) of Libya in 2011 to that in 2012?
Your answer should be compact. 0.84. What is the ratio of the Imports (% of total merchandise imports) of Philippines in 2011 to that in 2012?
Provide a short and direct response. 0.82. What is the ratio of the Imports (% of total merchandise imports) in Tunisia in 2011 to that in 2012?
Offer a terse response. 0.85. What is the difference between the highest and the second highest Imports (% of total merchandise imports) of Libya?
Your answer should be very brief. 2.17. What is the difference between the highest and the second highest Imports (% of total merchandise imports) in Philippines?
Provide a short and direct response. 0.31. What is the difference between the highest and the second highest Imports (% of total merchandise imports) in Tunisia?
Provide a succinct answer. 1.28. What is the difference between the highest and the lowest Imports (% of total merchandise imports) of Libya?
Make the answer very short. 7.51. What is the difference between the highest and the lowest Imports (% of total merchandise imports) in Philippines?
Your response must be concise. 0.48. What is the difference between the highest and the lowest Imports (% of total merchandise imports) of Tunisia?
Provide a succinct answer. 3.75. 